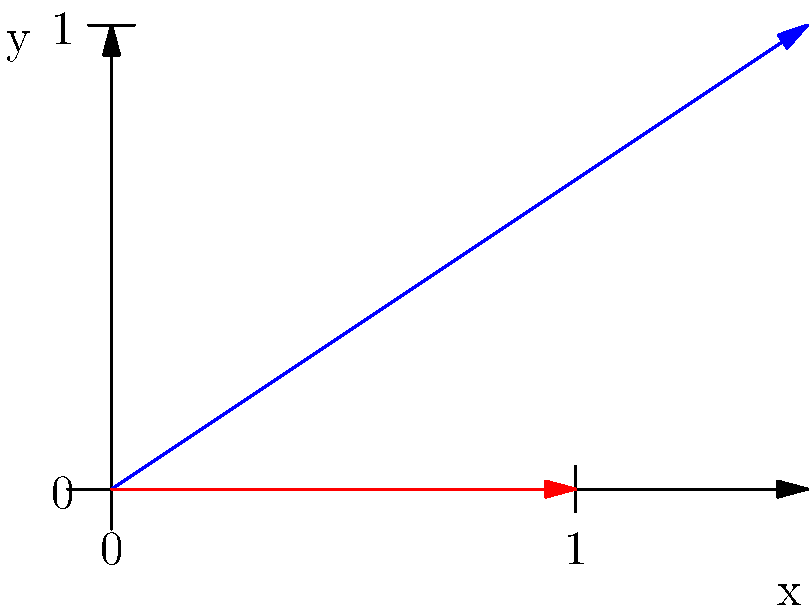A carrier pigeon is released from a medieval castle to deliver a message. The pigeon's natural flight path is represented by the blue vector, while the red vector shows the wind direction and strength. If the pigeon's speed is 40 km/h and the wind speed is 30 km/h, what is the magnitude of the resultant velocity vector (green dashed line) in km/h? To solve this problem, we'll use vector addition and the Pythagorean theorem:

1. Identify the vectors:
   - Pigeon's path (blue): 40 km/h at 45° angle
   - Wind (red): 30 km/h horizontally

2. Break down the pigeon's velocity into x and y components:
   $v_{x} = 40 \cos(45°) = 40 \cdot \frac{\sqrt{2}}{2} \approx 28.28$ km/h
   $v_{y} = 40 \sin(45°) = 40 \cdot \frac{\sqrt{2}}{2} \approx 28.28$ km/h

3. Add the wind vector to the x-component:
   $v_{x_{total}} = 28.28 + 30 = 58.28$ km/h

4. The y-component remains unchanged:
   $v_{y_{total}} = 28.28$ km/h

5. Calculate the magnitude of the resultant vector using the Pythagorean theorem:
   $v_{resultant} = \sqrt{(v_{x_{total}})^2 + (v_{y_{total}})^2}$
   $v_{resultant} = \sqrt{(58.28)^2 + (28.28)^2}$
   $v_{resultant} = \sqrt{3396.57 + 800.16}$
   $v_{resultant} = \sqrt{4196.73}$
   $v_{resultant} \approx 64.78$ km/h
Answer: 64.78 km/h 